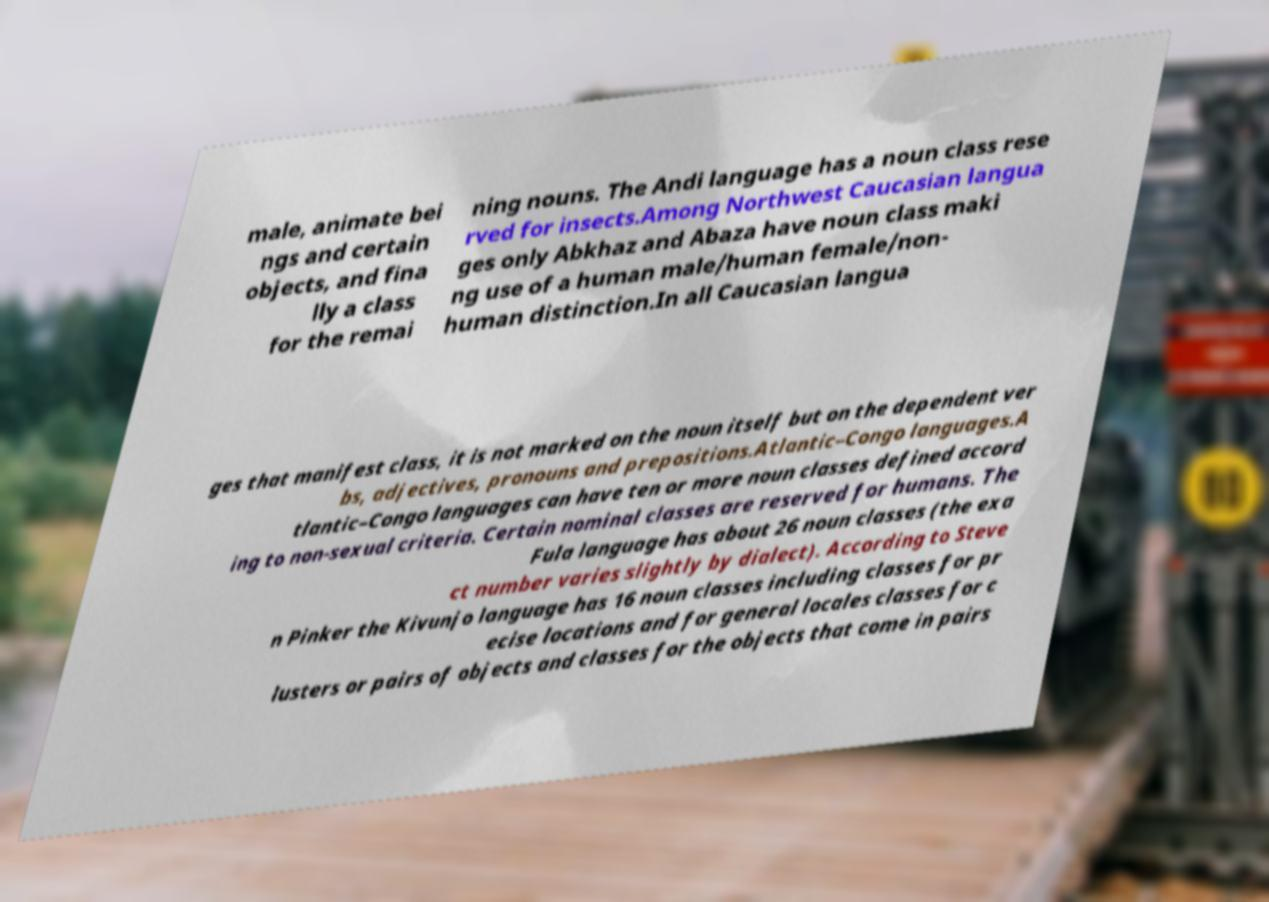What messages or text are displayed in this image? I need them in a readable, typed format. male, animate bei ngs and certain objects, and fina lly a class for the remai ning nouns. The Andi language has a noun class rese rved for insects.Among Northwest Caucasian langua ges only Abkhaz and Abaza have noun class maki ng use of a human male/human female/non- human distinction.In all Caucasian langua ges that manifest class, it is not marked on the noun itself but on the dependent ver bs, adjectives, pronouns and prepositions.Atlantic–Congo languages.A tlantic–Congo languages can have ten or more noun classes defined accord ing to non-sexual criteria. Certain nominal classes are reserved for humans. The Fula language has about 26 noun classes (the exa ct number varies slightly by dialect). According to Steve n Pinker the Kivunjo language has 16 noun classes including classes for pr ecise locations and for general locales classes for c lusters or pairs of objects and classes for the objects that come in pairs 